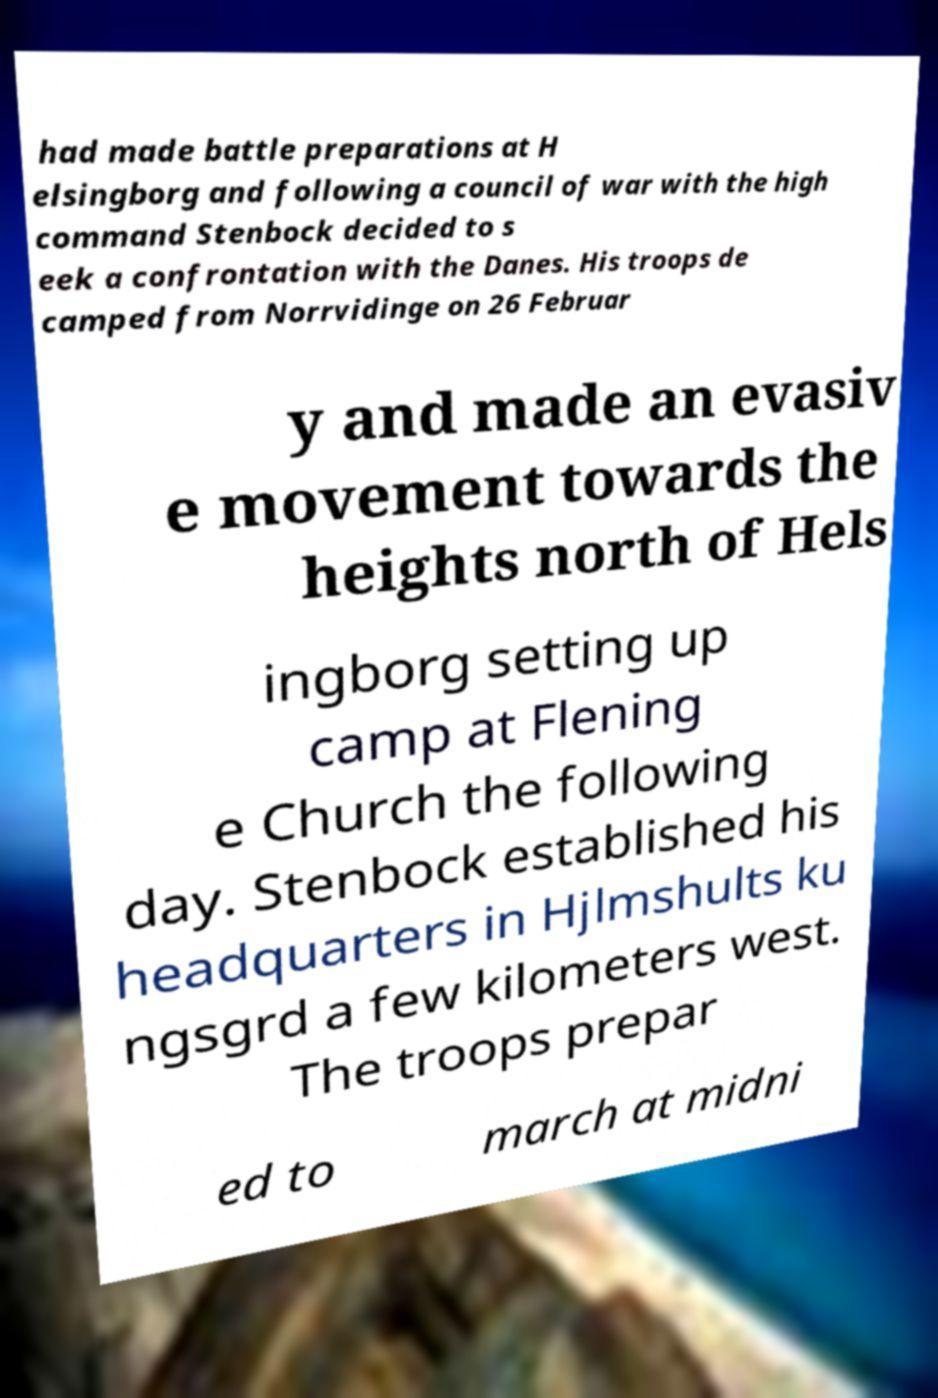Can you accurately transcribe the text from the provided image for me? had made battle preparations at H elsingborg and following a council of war with the high command Stenbock decided to s eek a confrontation with the Danes. His troops de camped from Norrvidinge on 26 Februar y and made an evasiv e movement towards the heights north of Hels ingborg setting up camp at Flening e Church the following day. Stenbock established his headquarters in Hjlmshults ku ngsgrd a few kilometers west. The troops prepar ed to march at midni 